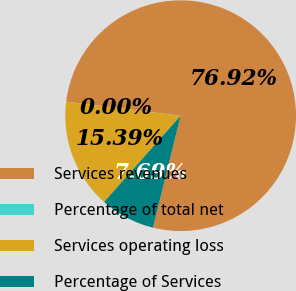<chart> <loc_0><loc_0><loc_500><loc_500><pie_chart><fcel>Services revenues<fcel>Percentage of total net<fcel>Services operating loss<fcel>Percentage of Services<nl><fcel>76.92%<fcel>0.0%<fcel>15.39%<fcel>7.69%<nl></chart> 